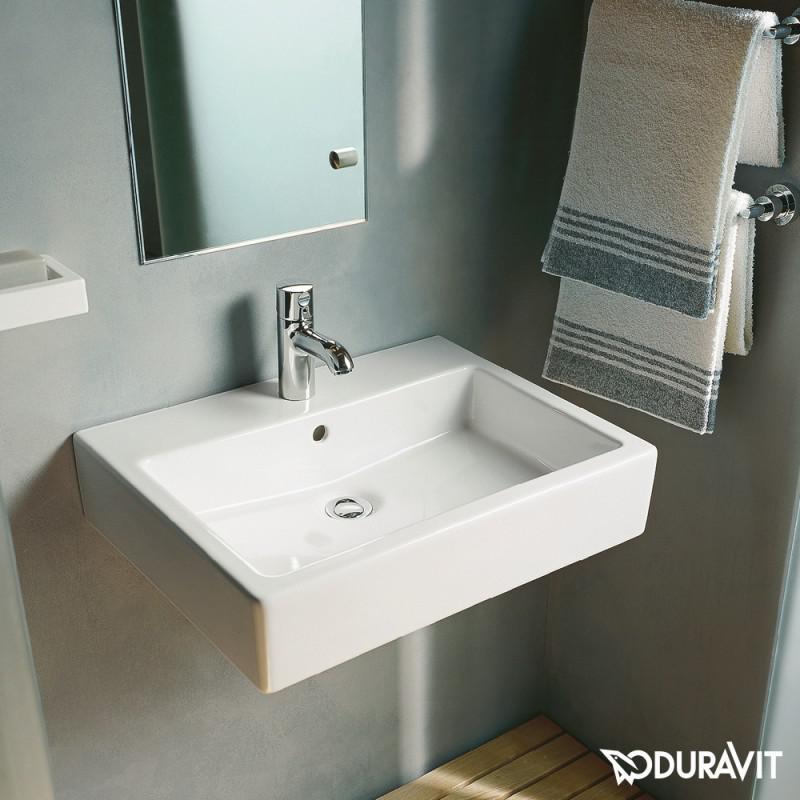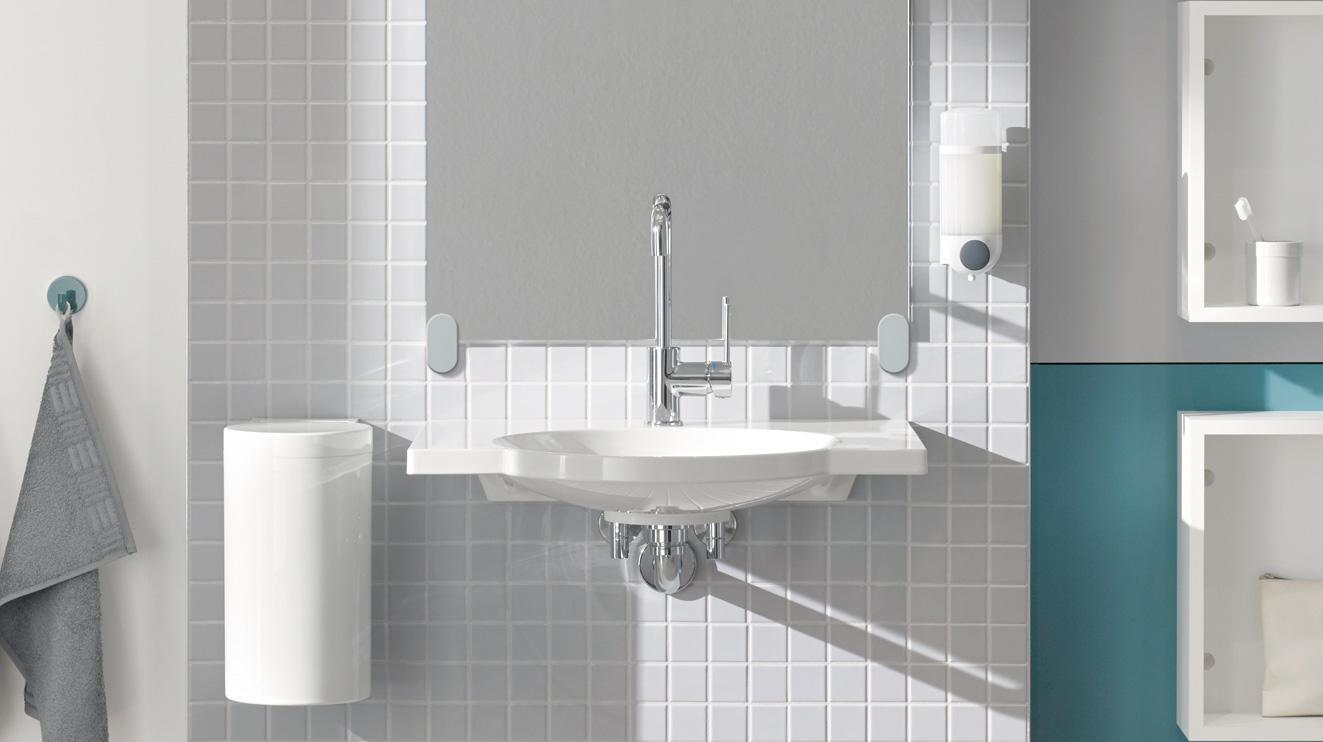The first image is the image on the left, the second image is the image on the right. Assess this claim about the two images: "The right image includes a tankless wall-mounted white toilet behind a similarly shaped wall-mounted white sink.". Correct or not? Answer yes or no. No. The first image is the image on the left, the second image is the image on the right. Evaluate the accuracy of this statement regarding the images: "In one image a sink with chrome faucet and a commode, both white, are mounted side by side on a wall.". Is it true? Answer yes or no. No. 